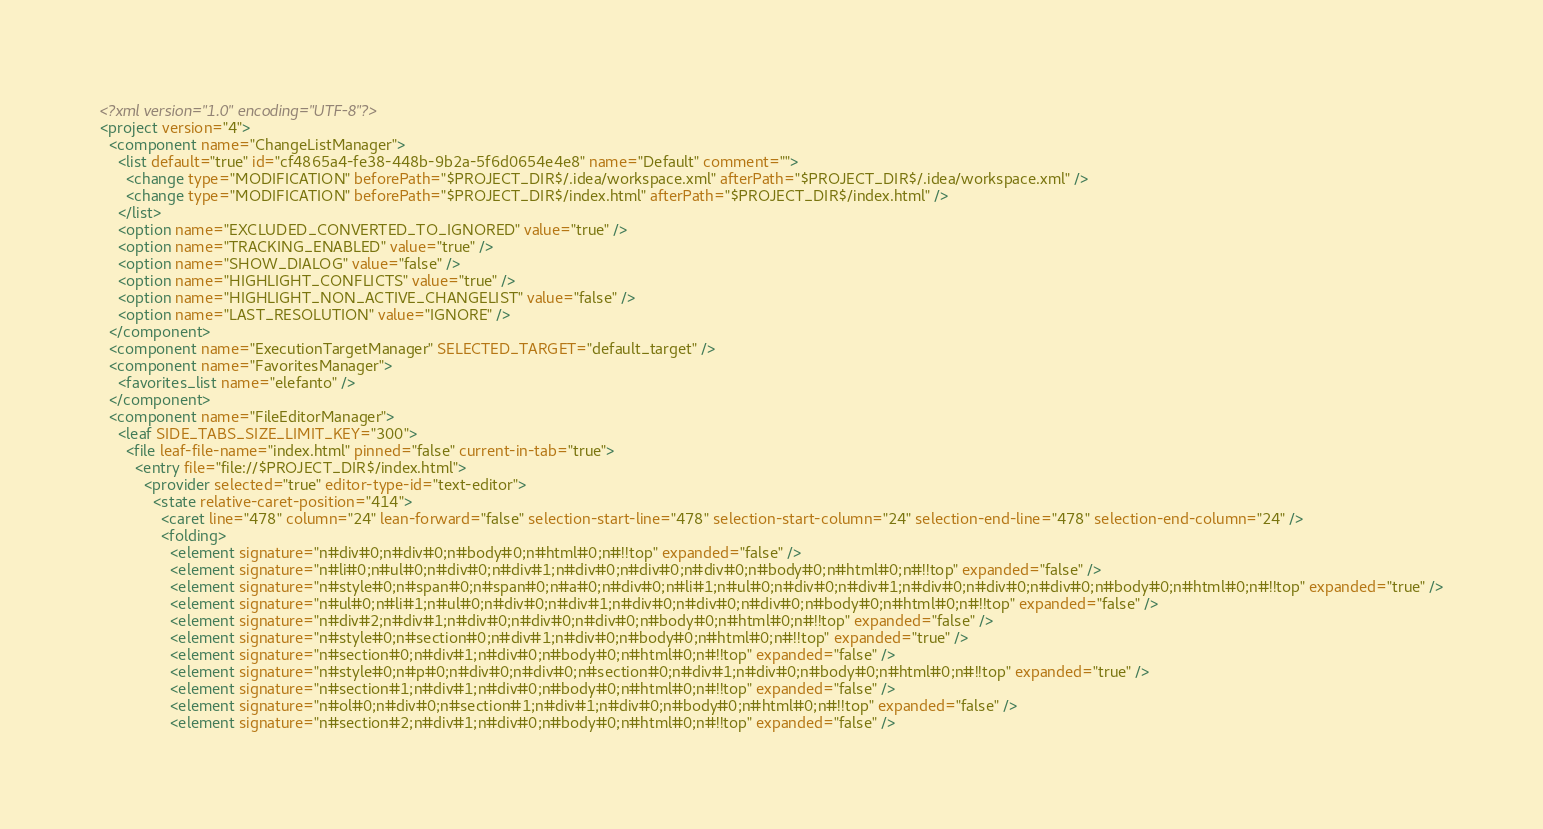Convert code to text. <code><loc_0><loc_0><loc_500><loc_500><_XML_><?xml version="1.0" encoding="UTF-8"?>
<project version="4">
  <component name="ChangeListManager">
    <list default="true" id="cf4865a4-fe38-448b-9b2a-5f6d0654e4e8" name="Default" comment="">
      <change type="MODIFICATION" beforePath="$PROJECT_DIR$/.idea/workspace.xml" afterPath="$PROJECT_DIR$/.idea/workspace.xml" />
      <change type="MODIFICATION" beforePath="$PROJECT_DIR$/index.html" afterPath="$PROJECT_DIR$/index.html" />
    </list>
    <option name="EXCLUDED_CONVERTED_TO_IGNORED" value="true" />
    <option name="TRACKING_ENABLED" value="true" />
    <option name="SHOW_DIALOG" value="false" />
    <option name="HIGHLIGHT_CONFLICTS" value="true" />
    <option name="HIGHLIGHT_NON_ACTIVE_CHANGELIST" value="false" />
    <option name="LAST_RESOLUTION" value="IGNORE" />
  </component>
  <component name="ExecutionTargetManager" SELECTED_TARGET="default_target" />
  <component name="FavoritesManager">
    <favorites_list name="elefanto" />
  </component>
  <component name="FileEditorManager">
    <leaf SIDE_TABS_SIZE_LIMIT_KEY="300">
      <file leaf-file-name="index.html" pinned="false" current-in-tab="true">
        <entry file="file://$PROJECT_DIR$/index.html">
          <provider selected="true" editor-type-id="text-editor">
            <state relative-caret-position="414">
              <caret line="478" column="24" lean-forward="false" selection-start-line="478" selection-start-column="24" selection-end-line="478" selection-end-column="24" />
              <folding>
                <element signature="n#div#0;n#div#0;n#body#0;n#html#0;n#!!top" expanded="false" />
                <element signature="n#li#0;n#ul#0;n#div#0;n#div#1;n#div#0;n#div#0;n#div#0;n#body#0;n#html#0;n#!!top" expanded="false" />
                <element signature="n#style#0;n#span#0;n#span#0;n#a#0;n#div#0;n#li#1;n#ul#0;n#div#0;n#div#1;n#div#0;n#div#0;n#div#0;n#body#0;n#html#0;n#!!top" expanded="true" />
                <element signature="n#ul#0;n#li#1;n#ul#0;n#div#0;n#div#1;n#div#0;n#div#0;n#div#0;n#body#0;n#html#0;n#!!top" expanded="false" />
                <element signature="n#div#2;n#div#1;n#div#0;n#div#0;n#div#0;n#body#0;n#html#0;n#!!top" expanded="false" />
                <element signature="n#style#0;n#section#0;n#div#1;n#div#0;n#body#0;n#html#0;n#!!top" expanded="true" />
                <element signature="n#section#0;n#div#1;n#div#0;n#body#0;n#html#0;n#!!top" expanded="false" />
                <element signature="n#style#0;n#p#0;n#div#0;n#div#0;n#section#0;n#div#1;n#div#0;n#body#0;n#html#0;n#!!top" expanded="true" />
                <element signature="n#section#1;n#div#1;n#div#0;n#body#0;n#html#0;n#!!top" expanded="false" />
                <element signature="n#ol#0;n#div#0;n#section#1;n#div#1;n#div#0;n#body#0;n#html#0;n#!!top" expanded="false" />
                <element signature="n#section#2;n#div#1;n#div#0;n#body#0;n#html#0;n#!!top" expanded="false" /></code> 